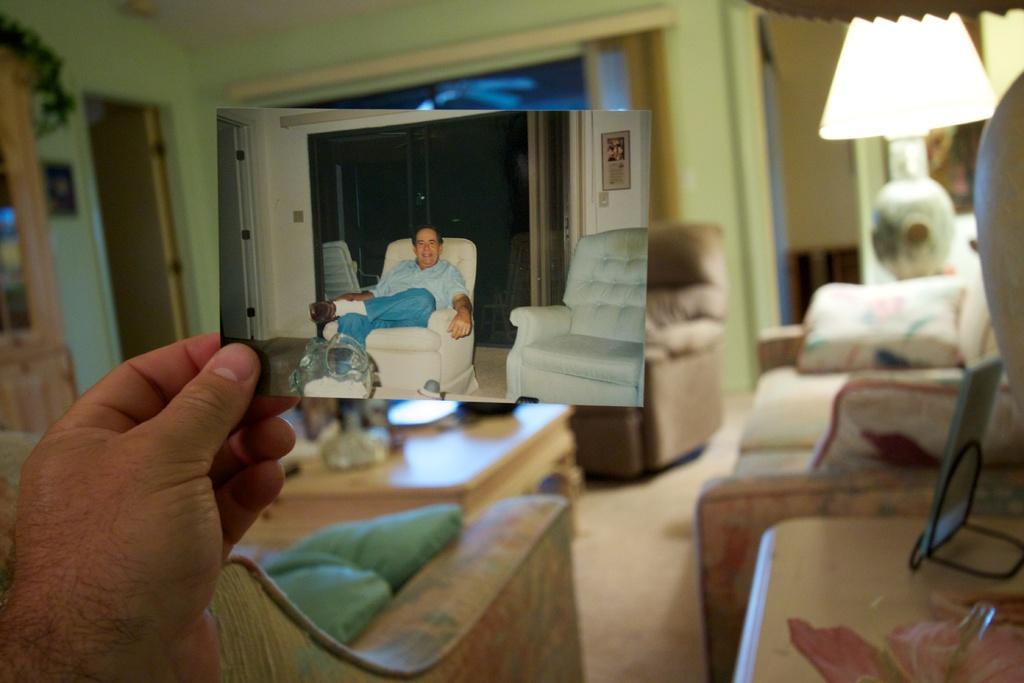Could you give a brief overview of what you see in this image? In this image in the front hand there is a hand of the person holding a photograph. On the right side there is a lamp and there is a sofa and on the table there is a frame. In the center there is a table and in front of the table there is a sofa. In the background there is a window, this is a door and there is a sofa. 